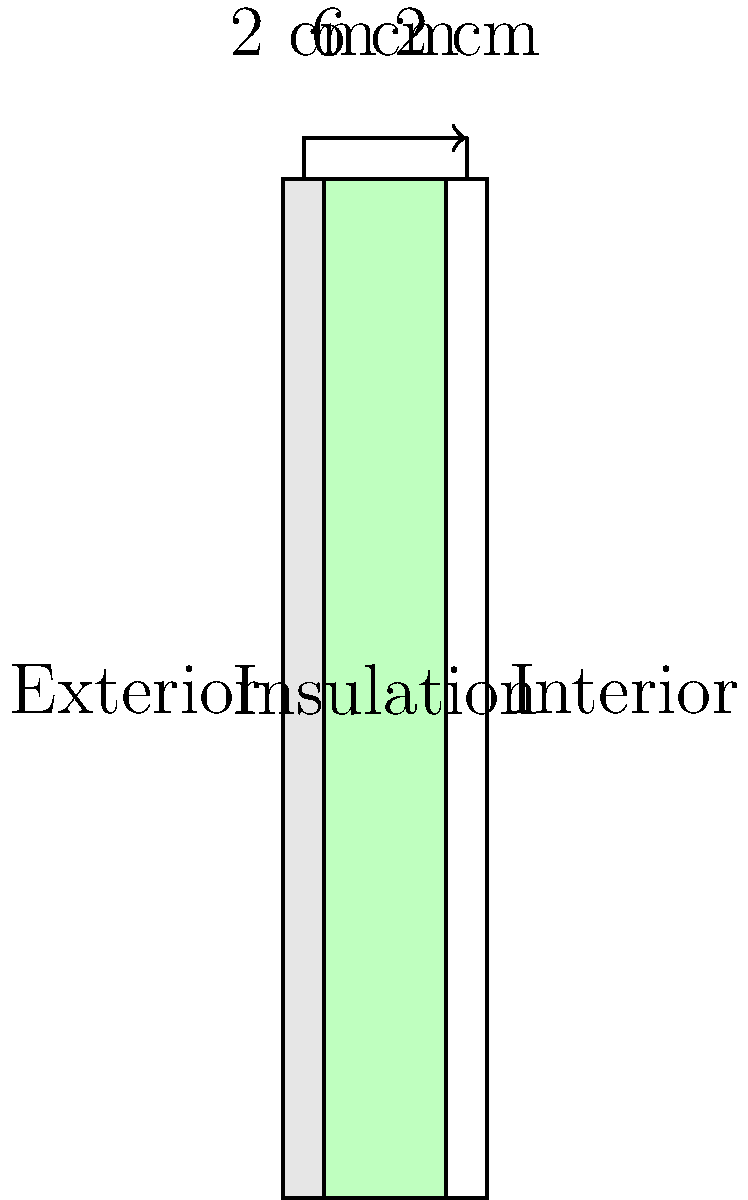A cross-sectional view of a wall is shown above. The wall consists of three layers: exterior sheathing (2 cm), insulation (6 cm), and interior drywall (2 cm). If the local building code requires a minimum R-value of 13 for exterior walls, and the R-value per inch of the insulation material is 3.8, determine whether the current insulation thickness meets the energy efficiency standards. If not, calculate the minimum thickness of insulation required to meet the standards. Let's approach this step-by-step:

1. Convert the given R-value per inch to R-value per cm:
   $3.8 \text{ per inch} = 3.8 / 2.54 \approx 1.5 \text{ per cm}$

2. Calculate the current R-value of the insulation:
   $R_{\text{insulation}} = 6 \text{ cm} \times 1.5 \text{ per cm} = 9$

3. Assume negligible R-values for the exterior sheathing and interior drywall.

4. Compare the current R-value to the required R-value:
   Current: 9 < Required: 13

5. Calculate the minimum thickness of insulation needed:
   $13 = x \text{ cm} \times 1.5 \text{ per cm}$
   $x = 13 / 1.5 \approx 8.67 \text{ cm}$

6. Round up to the nearest whole number: 9 cm

Therefore, the current insulation thickness does not meet the energy efficiency standards. The minimum thickness of insulation required is 9 cm.
Answer: No; 9 cm 